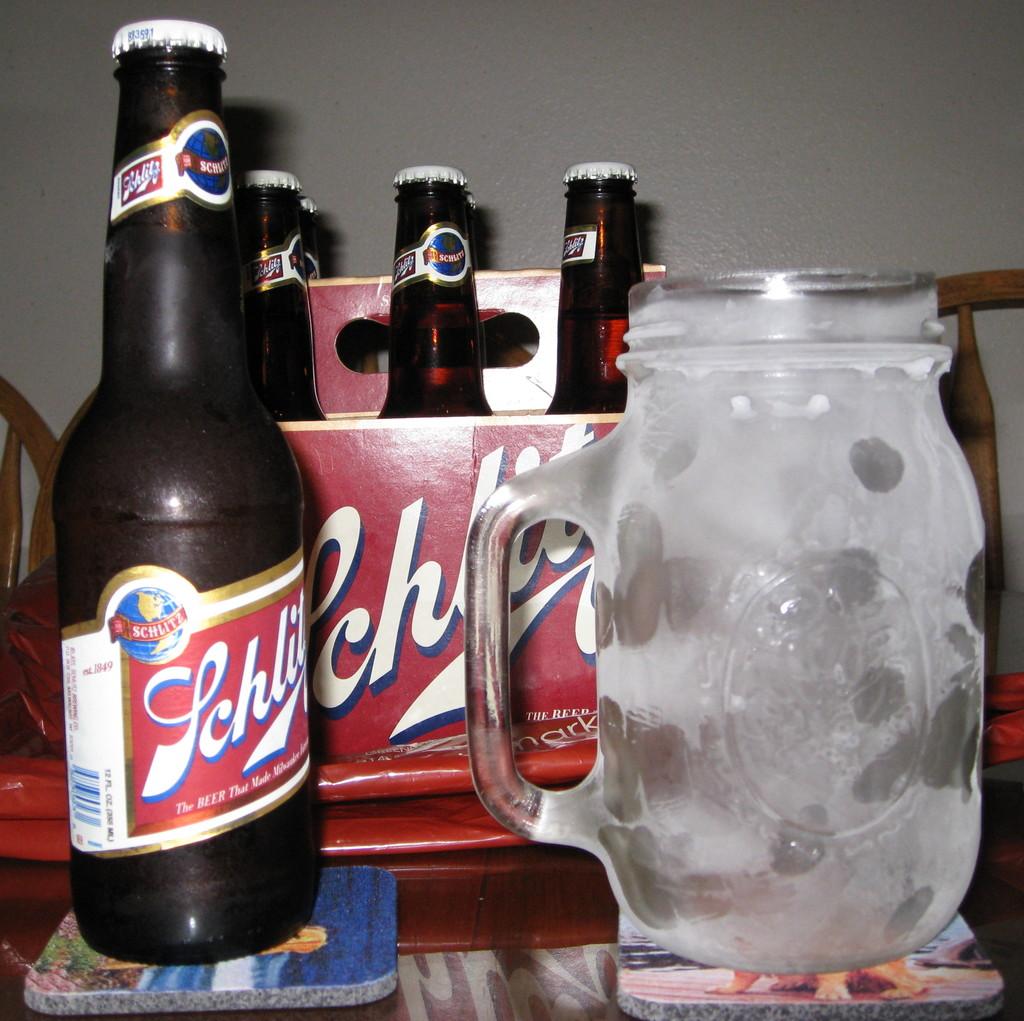What's the name of the beer on the left?
Make the answer very short. Schlitz. What type of beverage is in the bottle?
Provide a succinct answer. Beer. 